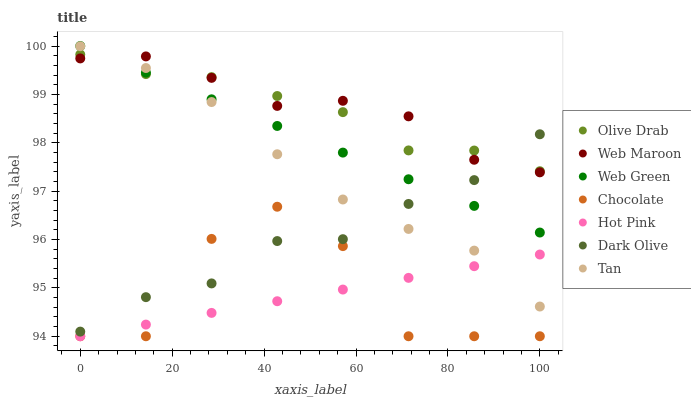Does Hot Pink have the minimum area under the curve?
Answer yes or no. Yes. Does Web Maroon have the maximum area under the curve?
Answer yes or no. Yes. Does Dark Olive have the minimum area under the curve?
Answer yes or no. No. Does Dark Olive have the maximum area under the curve?
Answer yes or no. No. Is Web Green the smoothest?
Answer yes or no. Yes. Is Chocolate the roughest?
Answer yes or no. Yes. Is Dark Olive the smoothest?
Answer yes or no. No. Is Dark Olive the roughest?
Answer yes or no. No. Does Hot Pink have the lowest value?
Answer yes or no. Yes. Does Dark Olive have the lowest value?
Answer yes or no. No. Does Web Green have the highest value?
Answer yes or no. Yes. Does Dark Olive have the highest value?
Answer yes or no. No. Is Chocolate less than Tan?
Answer yes or no. Yes. Is Web Maroon greater than Chocolate?
Answer yes or no. Yes. Does Web Maroon intersect Olive Drab?
Answer yes or no. Yes. Is Web Maroon less than Olive Drab?
Answer yes or no. No. Is Web Maroon greater than Olive Drab?
Answer yes or no. No. Does Chocolate intersect Tan?
Answer yes or no. No. 